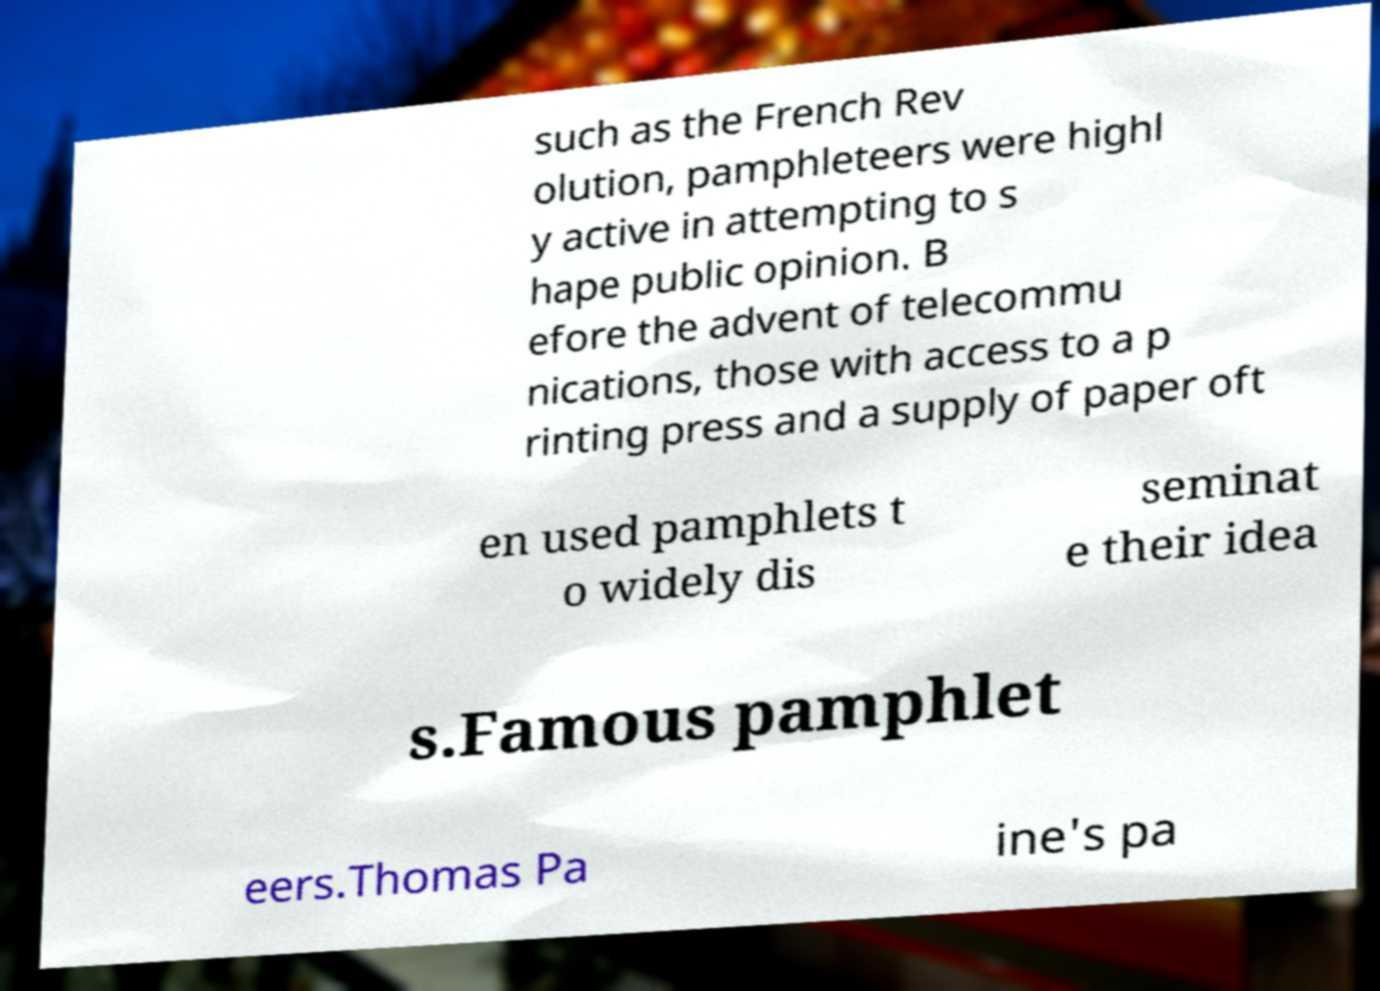Can you accurately transcribe the text from the provided image for me? such as the French Rev olution, pamphleteers were highl y active in attempting to s hape public opinion. B efore the advent of telecommu nications, those with access to a p rinting press and a supply of paper oft en used pamphlets t o widely dis seminat e their idea s.Famous pamphlet eers.Thomas Pa ine's pa 